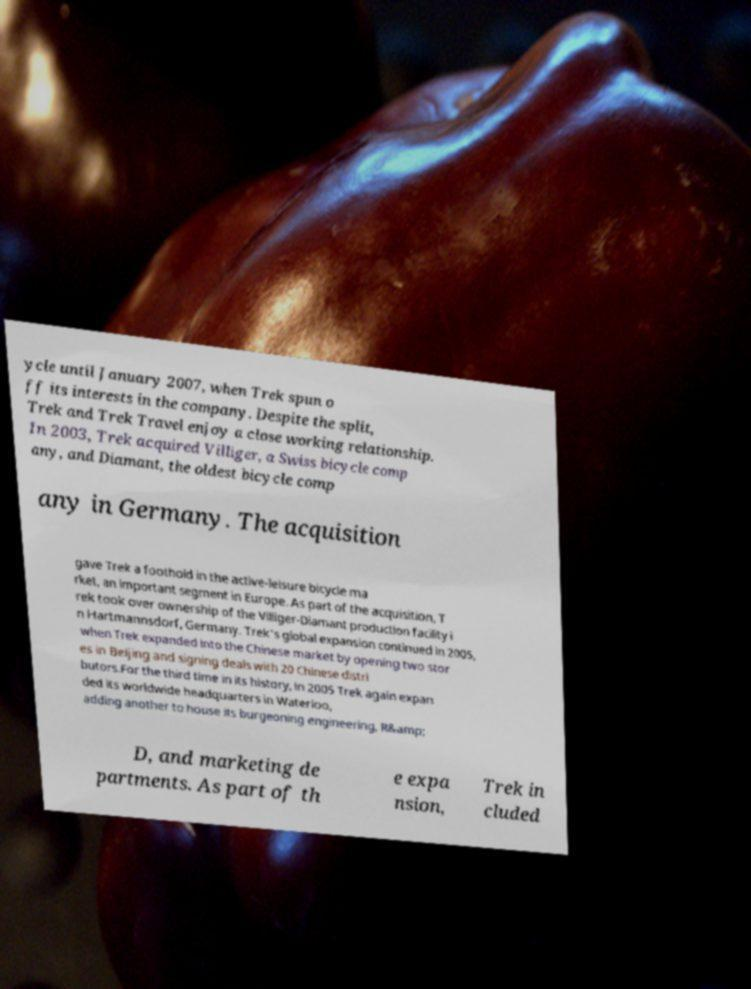For documentation purposes, I need the text within this image transcribed. Could you provide that? ycle until January 2007, when Trek spun o ff its interests in the company. Despite the split, Trek and Trek Travel enjoy a close working relationship. In 2003, Trek acquired Villiger, a Swiss bicycle comp any, and Diamant, the oldest bicycle comp any in Germany. The acquisition gave Trek a foothold in the active-leisure bicycle ma rket, an important segment in Europe. As part of the acquisition, T rek took over ownership of the Villiger-Diamant production facility i n Hartmannsdorf, Germany. Trek's global expansion continued in 2005, when Trek expanded into the Chinese market by opening two stor es in Beijing and signing deals with 20 Chinese distri butors.For the third time in its history, in 2005 Trek again expan ded its worldwide headquarters in Waterloo, adding another to house its burgeoning engineering, R&amp; D, and marketing de partments. As part of th e expa nsion, Trek in cluded 